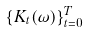Convert formula to latex. <formula><loc_0><loc_0><loc_500><loc_500>\{ K _ { t } ( \omega ) \} _ { t = 0 } ^ { T }</formula> 